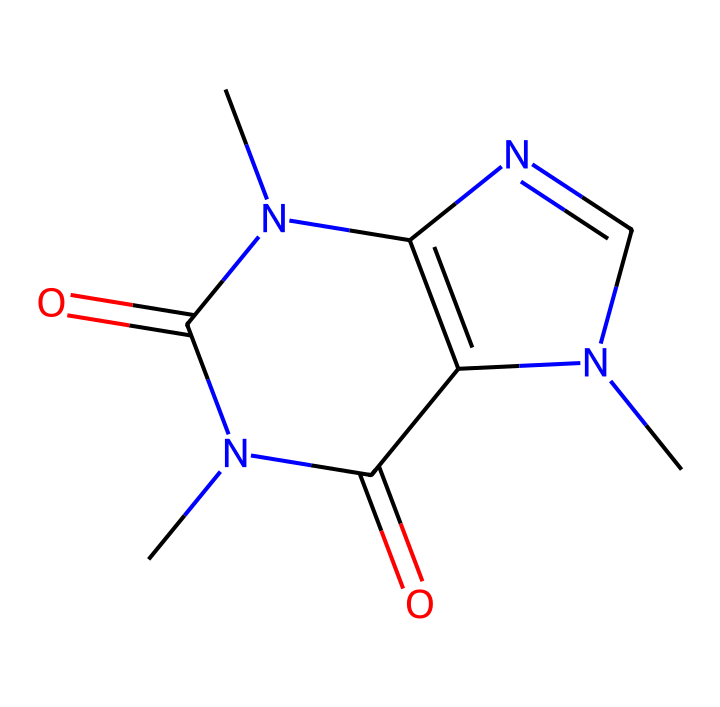What is the total number of nitrogen atoms in the chemical structure? By analyzing the SMILES representation, we can identify four nitrogen atoms (N) present in the structure. Counting from the SMILES notation, we see that there are distinct nitrogen symbols without being substituted or connected differently.
Answer: four How many carbon atoms are present in the caffeine structure? In the provided SMILES, we count the number of carbon atoms (C). There are eight carbon atoms, which can be identified at different points throughout the structure. The presence of letters 'C' indicates the locations of these carbon atoms.
Answer: eight What functional groups are indicated in the structure of caffeine? This caffeine structure features amide functional groups, seen by the presence of carbonyls (C=O) connected to nitrogen (N) atoms. These relationships highlight the presence of amide groups (R-CO-NR2) present in the compound.
Answer: amides What is the overall charge of the caffeine molecule? The molecular structure shows there are no formal charges displayed in the SMILES representation, indicating that the overall molecule is neutral and does not carry any charge. Therefore, we can conclude that the caffeine molecule holds a neutral charge.
Answer: neutral Does caffeine have a cyclic structure? Upon examining the provided structure's connections, we recognize that the presence of rings formed by carbon and nitrogen atoms indicates a cyclic compound. Therefore, we can conclude that caffeine has a cyclic structure based on its bonding pattern.
Answer: yes Which class of compounds does caffeine belong to based on its structure? Considering the structure and the complexity of the nitrogen and carbon composition, caffeine is categorized as an alkaloid, which is a naturally occurring compound commonly found in plants. The presence of nitrogen atoms in the ring structure contributes to its classification as an alkaloid.
Answer: alkaloid What is the type of bonding predominantly found in caffeine? Analyzing the SMILES representation, we observe that caffeine comprises covalent bonding, characterized by shared pairs of electrons between atoms. This involves the connection between carbon, nitrogen, and oxygen atoms, which indicates the dominant type of bonding in the caffeine structure.
Answer: covalent 